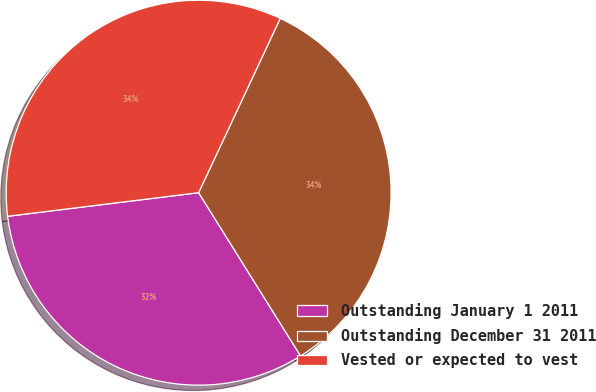Convert chart to OTSL. <chart><loc_0><loc_0><loc_500><loc_500><pie_chart><fcel>Outstanding January 1 2011<fcel>Outstanding December 31 2011<fcel>Vested or expected to vest<nl><fcel>31.93%<fcel>34.15%<fcel>33.93%<nl></chart> 